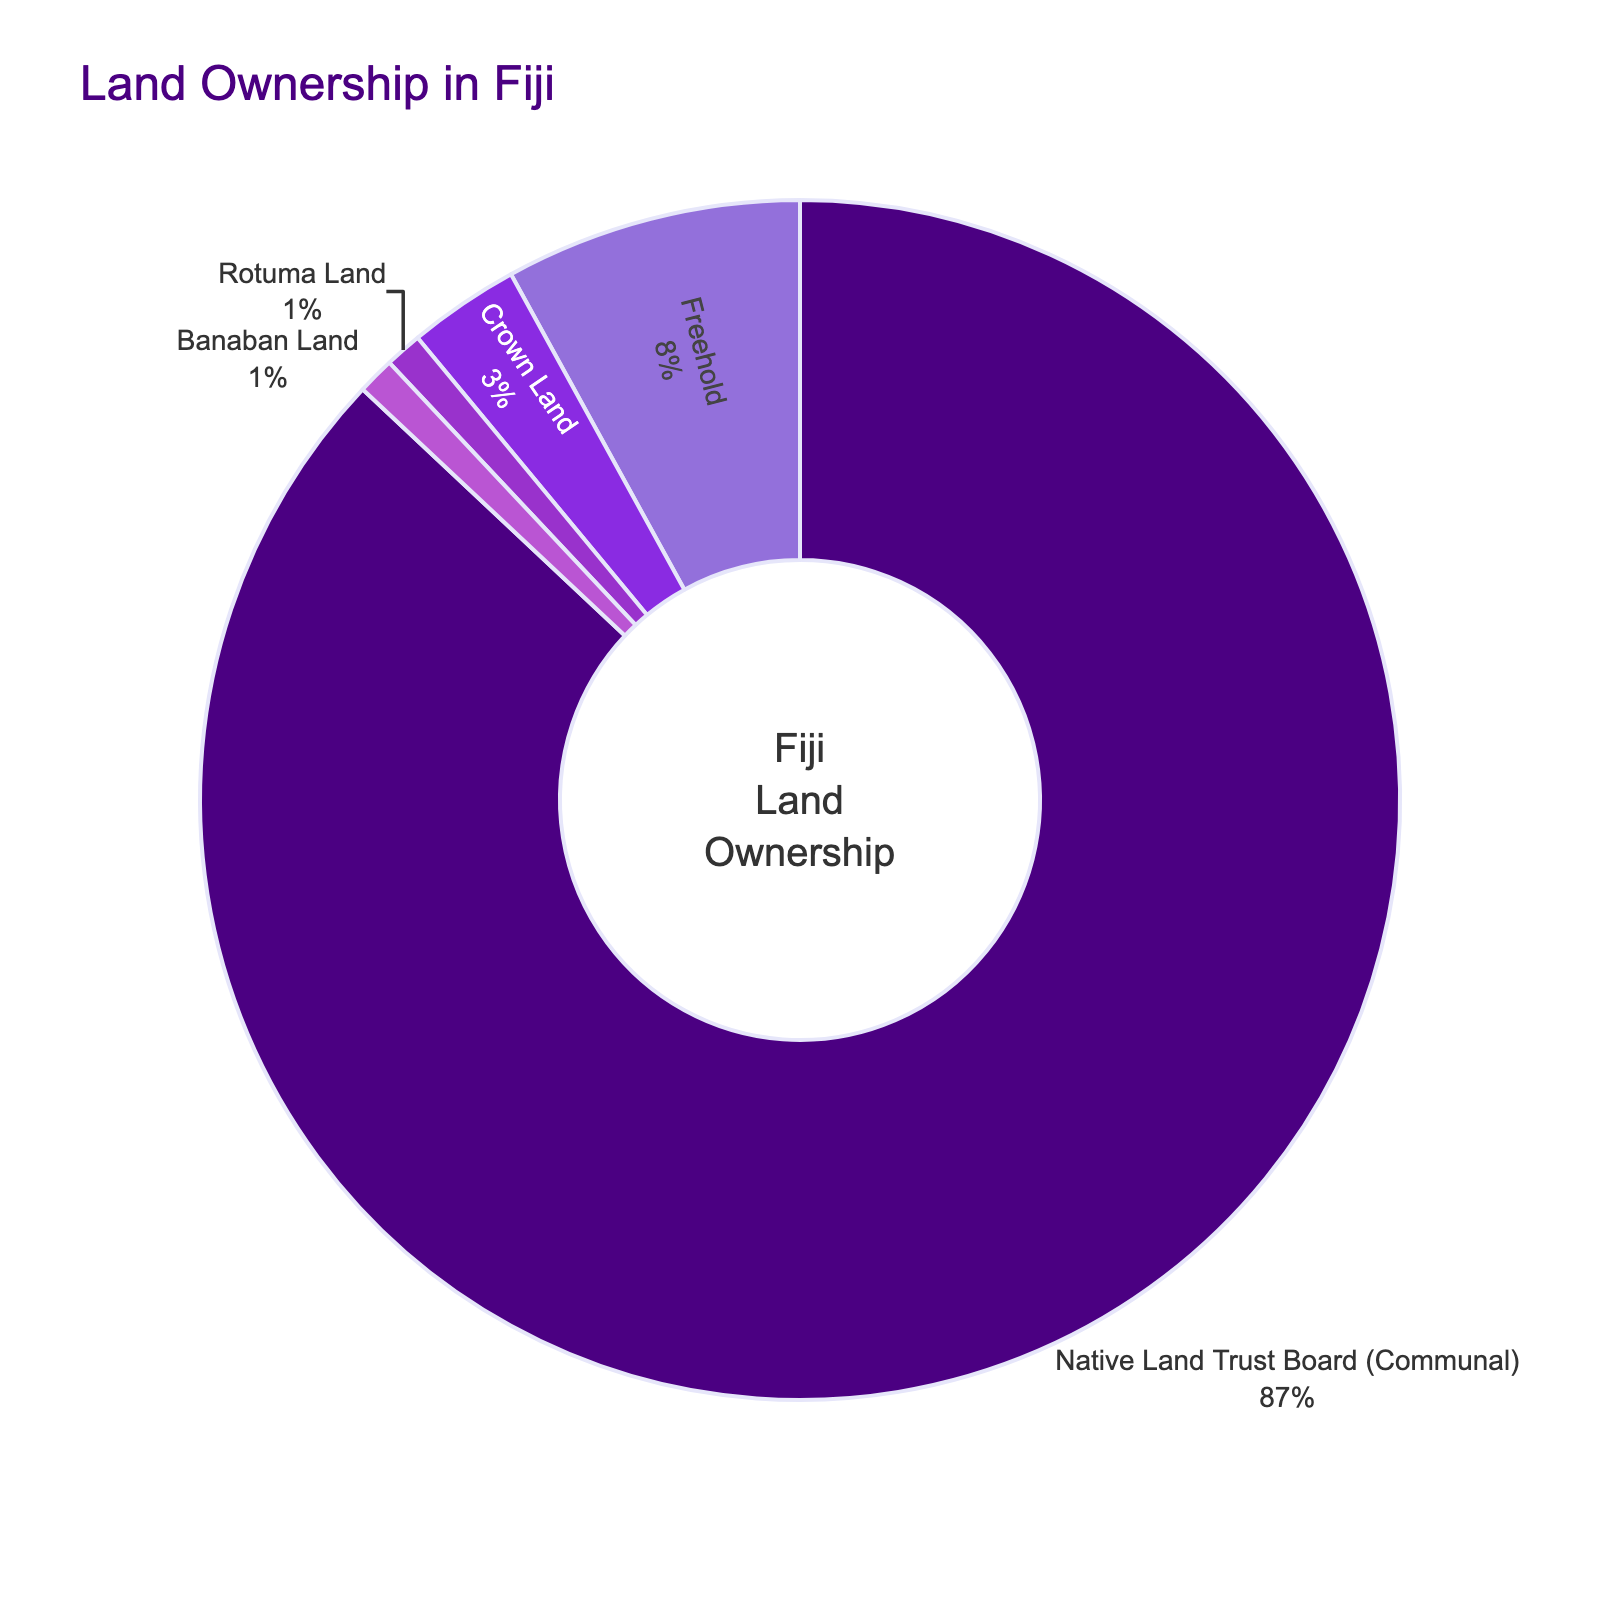What is the percentage of communal land in Fiji? The figure shows that the land owned by the Native Land Trust Board (Communal) is represented in one of the segments of the pie chart. By looking at the text labels, we can see this percentage is directly indicated.
Answer: 87% How does the percentage of freehold land compare to the combined percentage of Crown Land, Rotuma Land, and Banaban Land? We need to sum the percentages of Crown Land, Rotuma Land, and Banaban Land, which are 3%, 1%, and 1%. Then, compare this total (3 + 1 + 1 = 5%) with the percentage of freehold land (8%).
Answer: Freehold land is greater Which category of land ownership has the smallest percentage? By examining the pie chart and the percentages labeled, we can identify the smallest percentage. Both Rotuma Land and Banaban Land have the smallest percentage at 1%.
Answer: Rotuma Land and Banaban Land What is the total percentage of land that is not communal? We exclude the communal land percentage and sum the others: Freehold (8%) + Crown Land (3%) + Rotuma Land (1%) + Banaban Land (1%) = 13%.
Answer: 13% If the communal land were to decrease by 10%, what would be its new percentage? The current communal land percentage is 87%. A 10% decrease would be calculated as 87% - 10% = 77%.
Answer: 77% Which land ownership types combined have a percentage less than freehold land? We need to find the land ownership types where their combined percentage is less than 8%. Crown Land (3%), Rotuma Land (1%), and Banaban Land (1%) together add up to 5%, which is less than 8%.
Answer: Crown Land, Rotuma Land, and Banaban Land What is the difference in percentage between Native Land Trust Board (Communal) and Freehold land? The difference is calculated by subtracting the percentage of Freehold land (8%) from the communal land (87%). 87% - 8% = 79%.
Answer: 79% Which category's percentage is most visually prominent in the pie chart, and why? The Native Land Trust Board (Communal) segment is most visually prominent because it occupies the largest portion of the pie chart, as indicated by its percentage (87%).
Answer: Native Land Trust Board (Communal) If the Crown Land percentage increased by 2%, how would the new distribution of percentages look? Increase the Crown Land percentage from 3% to 5%. We then adjust the total to 102% (error), but logically, let's simply increase Crown Land percentage and recalculate. Total now: 87% + 8% + 5% + 1% + 1%. Note: This is hypothetical and not adjusting the total effectively; 87%, 8%, 5%, 1%, 1% in visual terms.
Answer: 87% (Communal), 8% (Freehold), 5% (Crown Land), 1% (Rotuma Land), 1% (Banaban Land) 